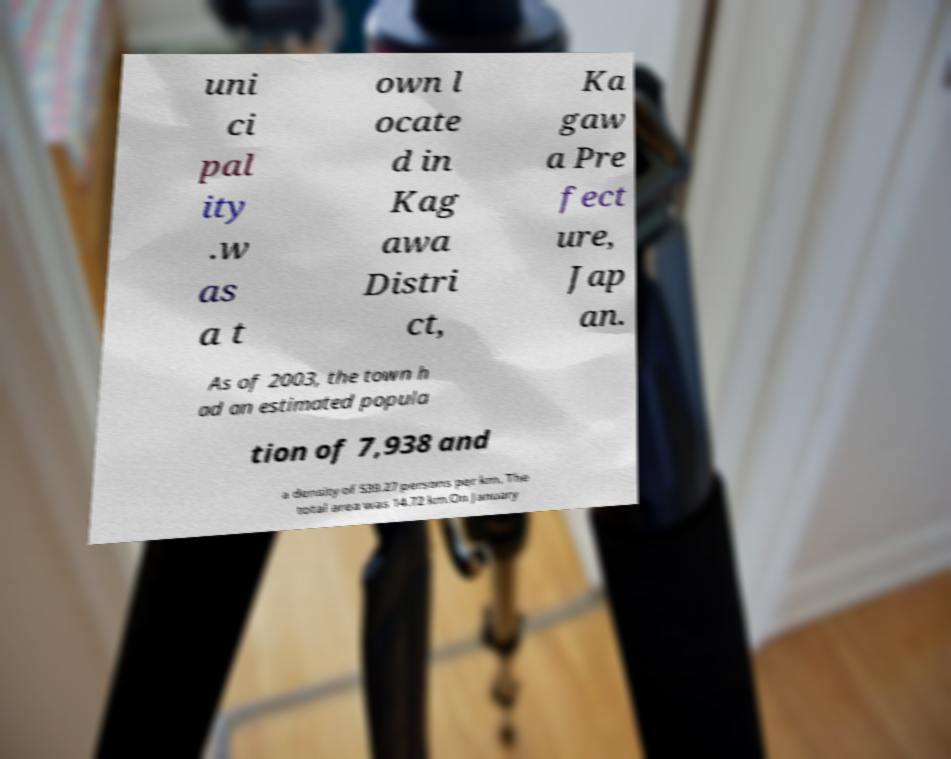For documentation purposes, I need the text within this image transcribed. Could you provide that? uni ci pal ity .w as a t own l ocate d in Kag awa Distri ct, Ka gaw a Pre fect ure, Jap an. As of 2003, the town h ad an estimated popula tion of 7,938 and a density of 539.27 persons per km. The total area was 14.72 km.On January 